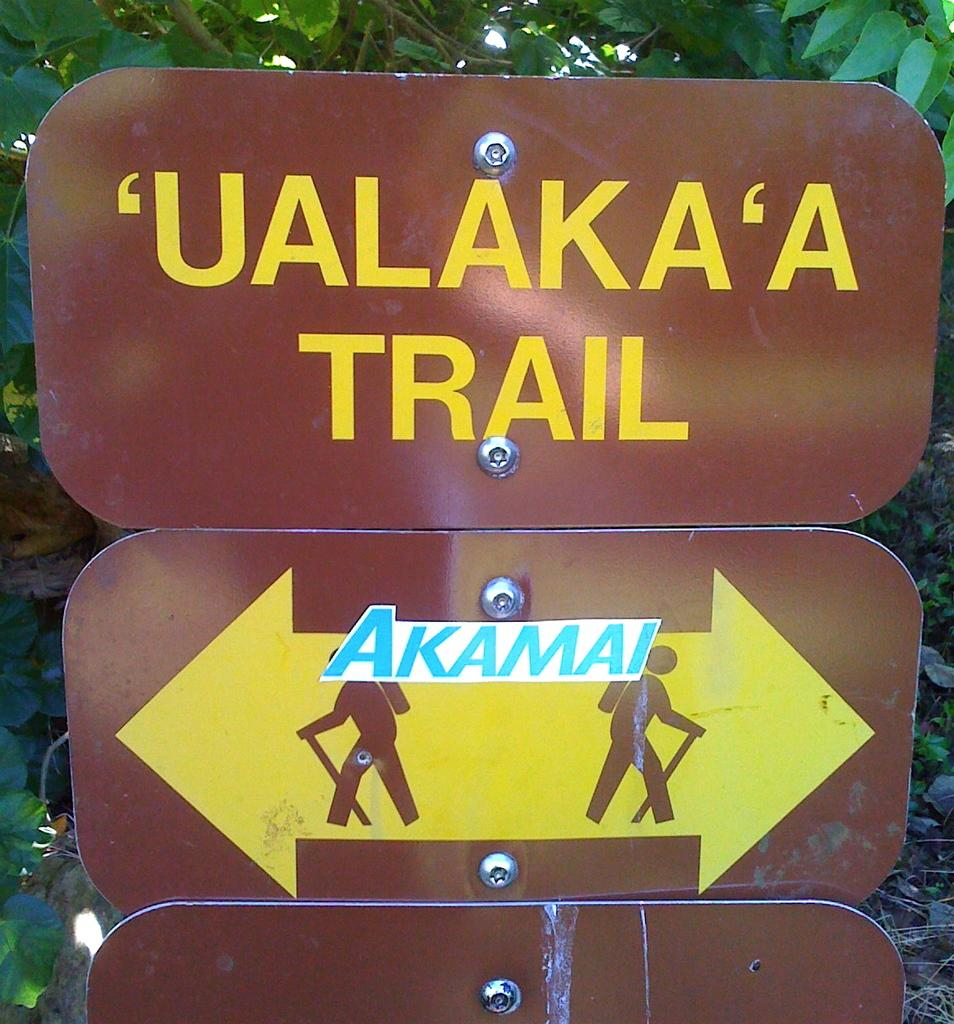How many boards are present in the image? There are three boards in the image. What feature do the boards have in common? The boards have screws. What is written on the boards? There is writing on the boards. What can be seen in the background of the image? There are trees visible behind the boards. What type of lunchroom activity is taking place in the image? There is no lunchroom or activity present in the image; it features three boards with screws and writing, along with trees in the background. 